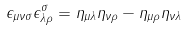Convert formula to latex. <formula><loc_0><loc_0><loc_500><loc_500>\epsilon _ { \mu \nu \sigma } \epsilon ^ { \sigma } _ { \lambda \rho } = \eta _ { \mu \lambda } \eta _ { \nu \rho } - \eta _ { \mu \rho } \eta _ { \nu \lambda }</formula> 